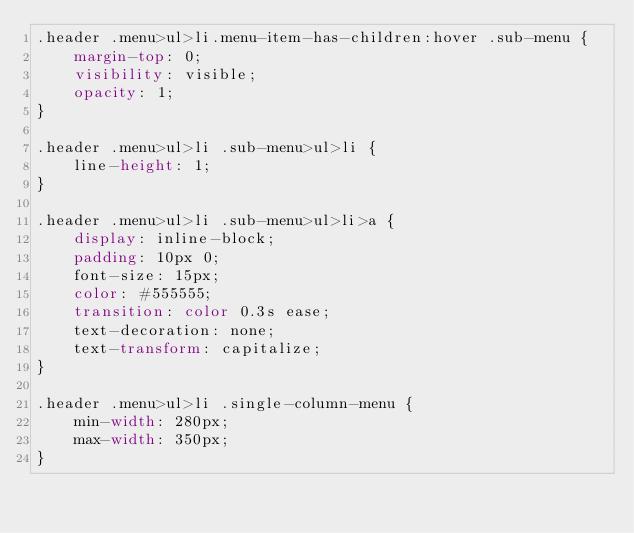Convert code to text. <code><loc_0><loc_0><loc_500><loc_500><_CSS_>.header .menu>ul>li.menu-item-has-children:hover .sub-menu {
    margin-top: 0;
    visibility: visible;
    opacity: 1;
}

.header .menu>ul>li .sub-menu>ul>li {
    line-height: 1;
}

.header .menu>ul>li .sub-menu>ul>li>a {
    display: inline-block;
    padding: 10px 0;
    font-size: 15px;
    color: #555555;
    transition: color 0.3s ease;
    text-decoration: none;
    text-transform: capitalize;
}

.header .menu>ul>li .single-column-menu {
    min-width: 280px;
    max-width: 350px;
}
</code> 